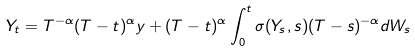<formula> <loc_0><loc_0><loc_500><loc_500>Y _ { t } = T ^ { - \alpha } ( T - t ) ^ { \alpha } y + ( T - t ) ^ { \alpha } \int _ { 0 } ^ { t } \sigma ( Y _ { s } , s ) ( T - s ) ^ { - \alpha } d W _ { s }</formula> 